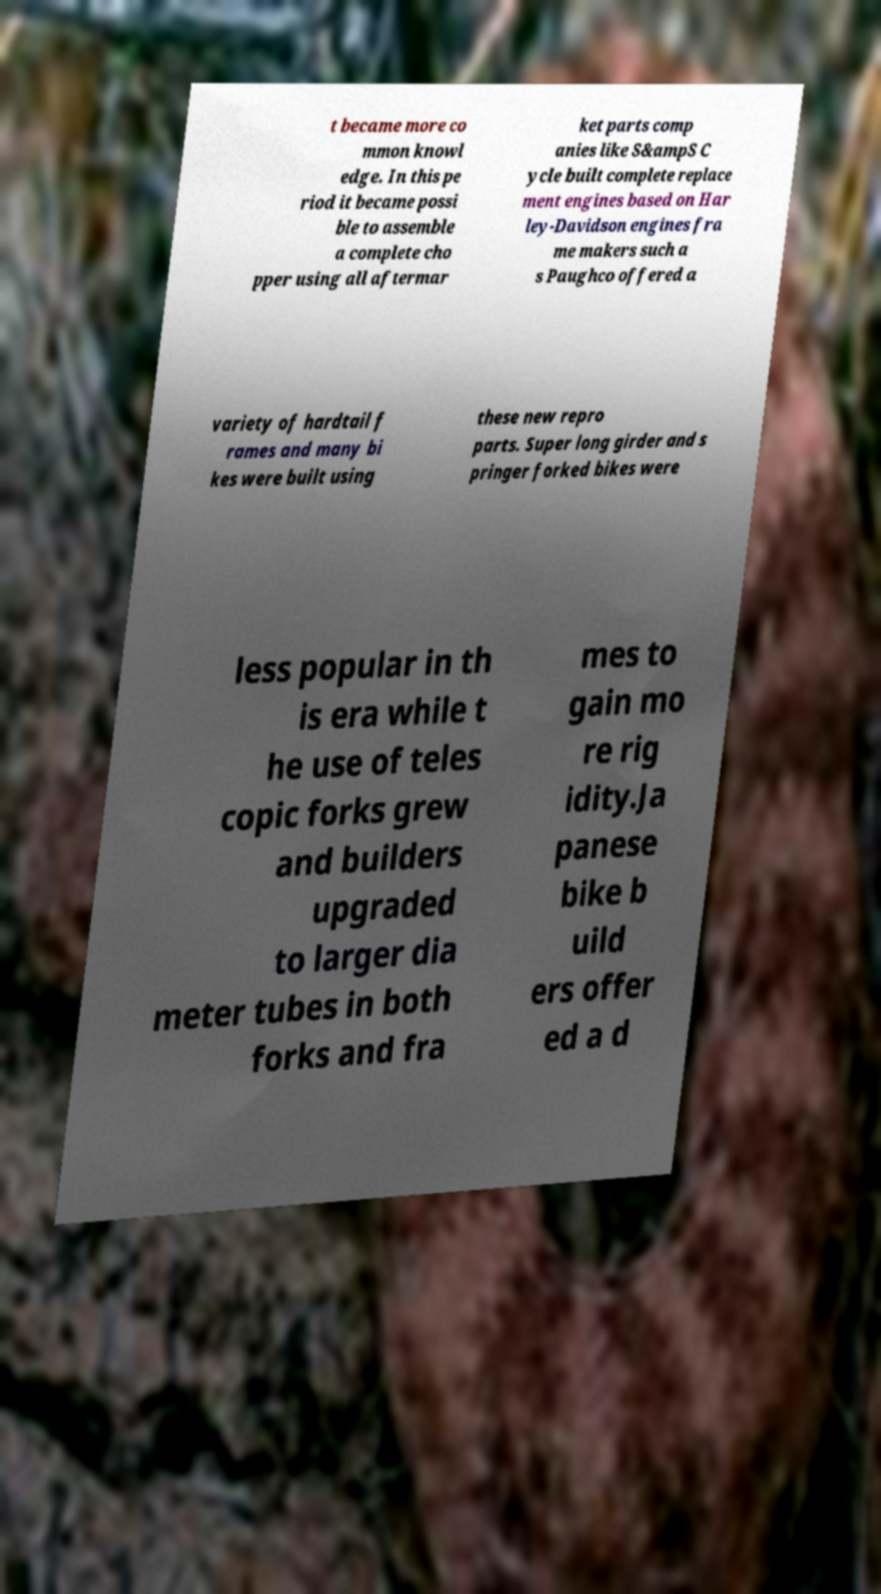Could you extract and type out the text from this image? t became more co mmon knowl edge. In this pe riod it became possi ble to assemble a complete cho pper using all aftermar ket parts comp anies like S&ampS C ycle built complete replace ment engines based on Har ley-Davidson engines fra me makers such a s Paughco offered a variety of hardtail f rames and many bi kes were built using these new repro parts. Super long girder and s pringer forked bikes were less popular in th is era while t he use of teles copic forks grew and builders upgraded to larger dia meter tubes in both forks and fra mes to gain mo re rig idity.Ja panese bike b uild ers offer ed a d 